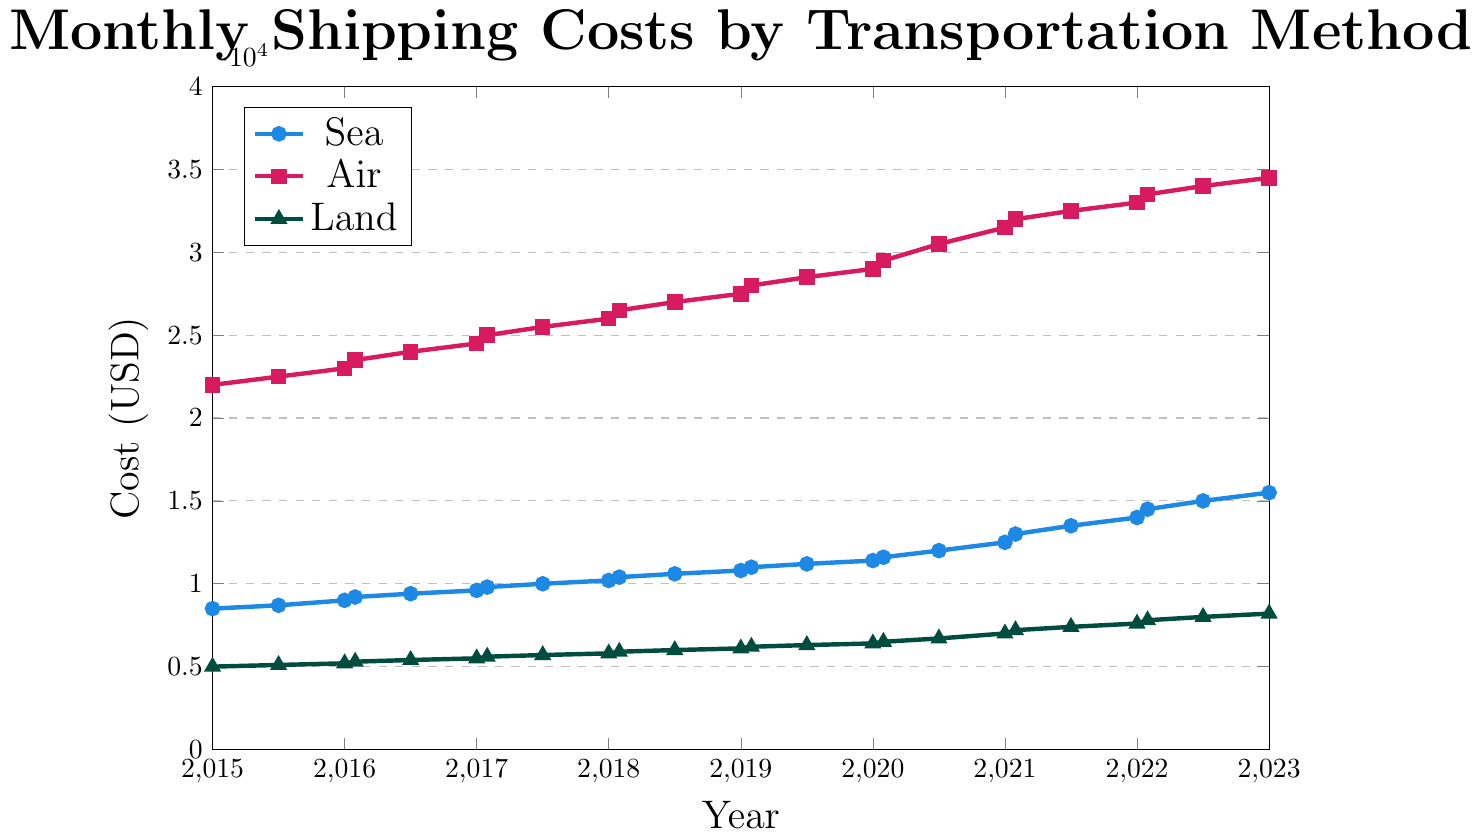Which transportation method has the highest shipping cost in 2023? Observe the values corresponding to the year 2023 for each method in the plot. The costs are Sea: $16,500, Air: $35,500, Land: $8,600. Air has the highest cost.
Answer: Air What was the cost difference between Sea and Air transportation in January 2022? For January 2022, the Sea cost is $14,500 and the Air cost is $33,500. The difference is calculated as $33,500 - $14,500 = $19,000.
Answer: $19,000 During which year did the cost for Land transportation first surpass $6,000? Observe the trend for Land transportation costs. In 2018, the cost was $6,000 in June, which is the first instance it reached or surpassed $6,000.
Answer: 2018 What is the average shipping cost for Sea transportation over the years 2018 and 2019? Calculate the average of the Sea costs for all the points between and including 2018 and 2019. Sea Costs: $10,400, $10,600, $10,800, $11,000, $11,200. Average = ($10,400 + $10,600 + $10,800 + $11,000 + $11,200) / 5 = $10,800.
Answer: $10,800 What is the trend for Air transportation costs from 2020 to 2023? Observe the points for Air transportation from 2020 to 2023. The costs increase steadily from $29,000 in 2020 to $35,500 in 2023.
Answer: Increasing Which transportation method showed the smallest incremental cost change from January 2019 to June 2019? Calculate the cost changes for each method from January 2019 to June 2019: 
Sea: $11,000 to $11,200 ($200 increase), 
Air: $28,000 to $28,500 ($500 increase), 
Land: $6,200 to $6,300 ($100 increase).
The smallest change is for Land transportation with a $100 increase.
Answer: Land What is the visual color code for Land transportation in the chart? The plot line for Land transportation is in green color, which is visually distinct in the chart.
Answer: Green In which year did the Sea transportation cost reach $10,000? Look for the year where the Sea cost is $10,000 in the plot. This occurs in June 2017.
Answer: 2017 By how much did the Air transportation cost increase from 2020 to 2021? Calculate the difference in Air costs between 2020 ($29,000) and 2021 ($32,000). The increase is $32,000 - $29,000 = $3,000.
Answer: $3,000 